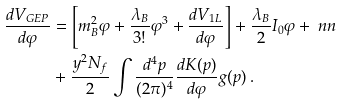Convert formula to latex. <formula><loc_0><loc_0><loc_500><loc_500>\frac { d V _ { G E P } } { d \varphi } & = \left [ m _ { B } ^ { 2 } \varphi + \frac { \lambda _ { B } } { 3 ! } \varphi ^ { 3 } + \frac { d V _ { 1 L } } { d \varphi } \right ] + \frac { \lambda _ { B } } { 2 } I _ { 0 } \varphi + \ n n \\ & + \frac { y ^ { 2 } N _ { f } } { 2 } \int \frac { d ^ { 4 } p } { ( 2 \pi ) ^ { 4 } } \frac { d K ( p ) } { d \varphi } g ( p ) \, .</formula> 